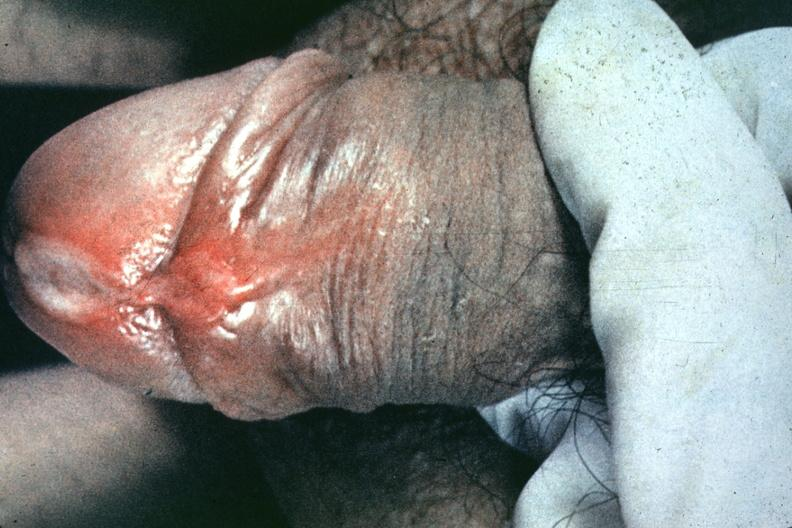what is present?
Answer the question using a single word or phrase. Chancre 